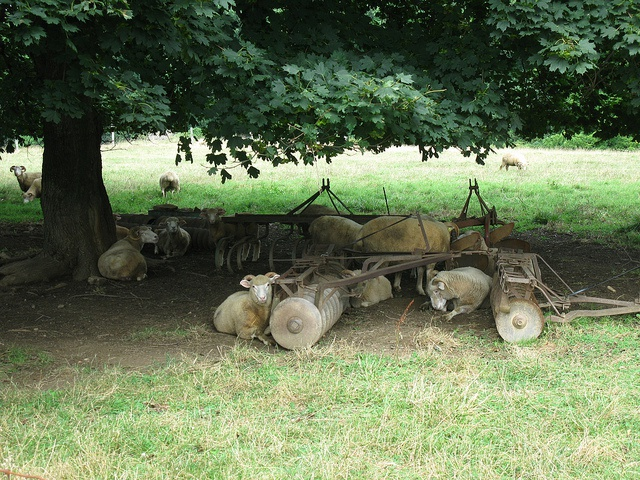Describe the objects in this image and their specific colors. I can see sheep in darkgreen, gray, olive, and black tones, sheep in darkgreen, gray, darkgray, and olive tones, sheep in darkgreen, black, and gray tones, sheep in darkgreen, gray, and darkgray tones, and sheep in darkgreen, black, and gray tones in this image. 